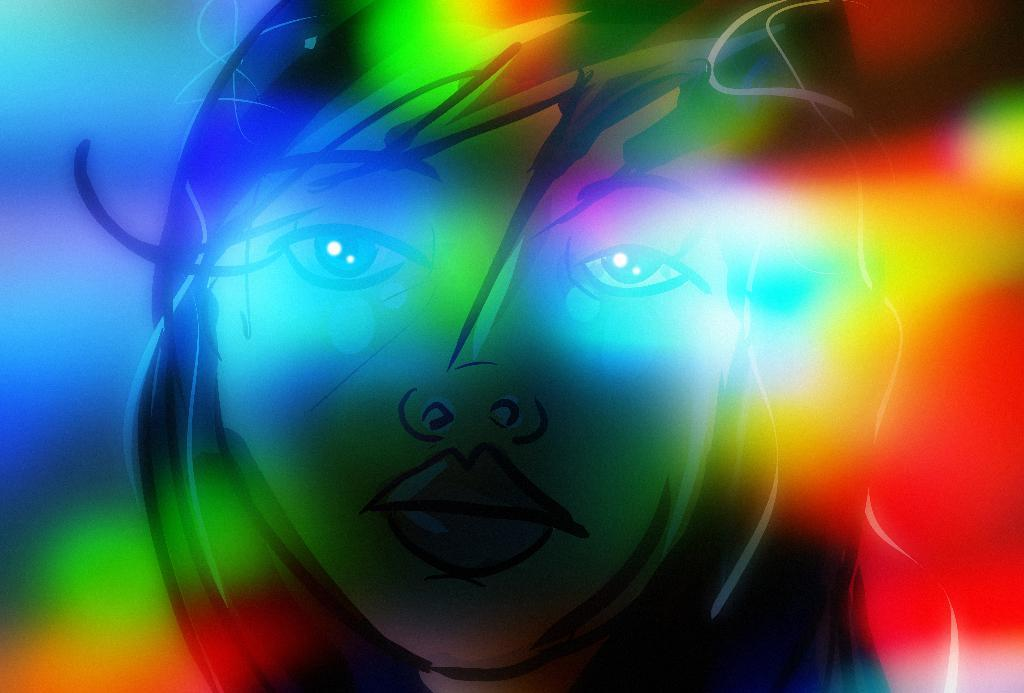What type of image is being described? The image is animated. What is the main subject of the image? The image depicts a woman's face. How many clocks are visible on the woman's face in the image? There are no clocks visible on the woman's face in the image. What type of bird can be seen flying around the woman's face in the image? There are no birds visible in the image, as it only depicts a woman's face. 